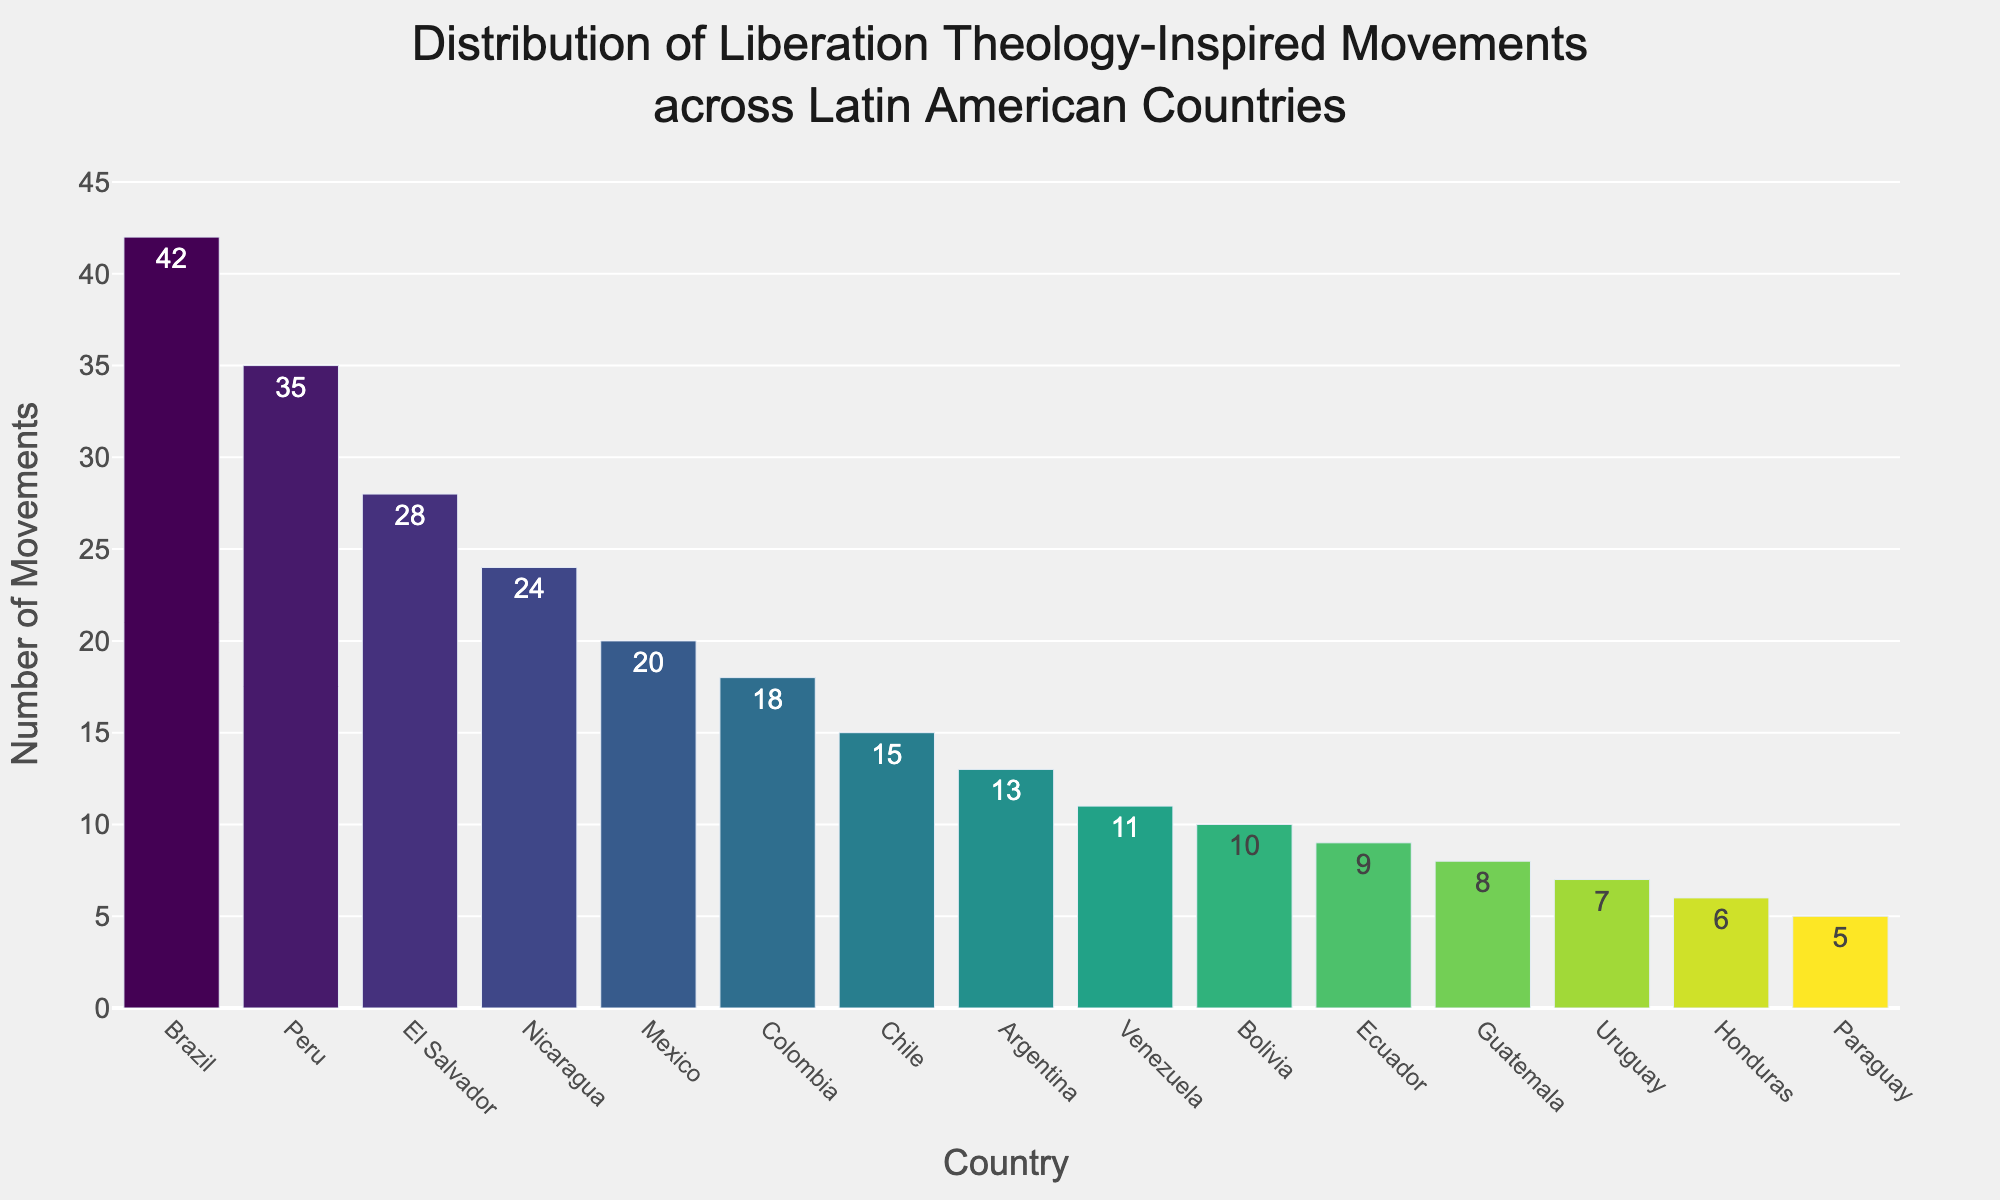What country has the highest number of liberation theology-inspired movements? By observing the heights of the bars or checking the values associated with each country, we can see that Brazil has the highest number of liberation theology-inspired movements with a count of 42, as its bar is the tallest.
Answer: Brazil Which country has fewer movements: Uruguay or Venezuela? By comparing the heights of the bars for Uruguay and Venezuela, we see that Uruguay has 7 movements and Venezuela has 11 movements, making Uruguay the country with fewer movements.
Answer: Uruguay How many liberation theology-inspired movements are there in total for the top three countries? The top three countries by the number of movements are Brazil (42), Peru (35), and El Salvador (28). Summing these values gives: 42 + 35 + 28 = 105
Answer: 105 Which country has a greater number of movements, Colombia or Chile? Comparing the bars for Colombia and Chile, Colombia has 18 movements while Chile has 15, thus Colombia has a greater number of movements.
Answer: Colombia What is the difference in the number of movements between the countries with the most and the least movements? The country with the most movements is Brazil (42) and the least is Paraguay (5). The difference is calculated as: 42 - 5 = 37
Answer: 37 What is the average number of liberation theology-inspired movements for Mexico, Argentina, and Bolivia? The number of movements in Mexico is 20, Argentina is 13, and Bolivia is 10. The average is calculated as: (20 + 13 + 10) / 3 = 43 / 3 ≈ 14.33
Answer: 14.33 Which two countries have the closest number of liberation theology-inspired movements? Observing the bar chart, the countries with the closest number of movements are Bolivia with 10 and Ecuador with 9, having only a one movement difference.
Answer: Bolivia and Ecuador What is the median number of movements in the dataset? Organize the number of movements: 5, 6, 7, 8, 9, 10, 11, 13, 15, 18, 20, 24, 28, 35, 42. Since there are 15 data points, the median is the 8th value: 13
Answer: 13 Which country has movements closest in number to the average for all countries? First, calculate the average: (42 + 35 + 28 + 24 + 20 + 18 + 15 + 13 + 11 + 10 + 9 + 8 + 7 + 6 + 5) / 15 = 251 / 15 ≈ 16.73. The country with the number closest to this average is Chile with 15 movements.
Answer: Chile How many total movements are represented in the bar chart? Sum the number of movements for all countries: 42 + 35 + 28 + 24 + 20 + 18 + 15 + 13 + 11 + 10 + 9 + 8 + 7 + 6 + 5 = 251
Answer: 251 